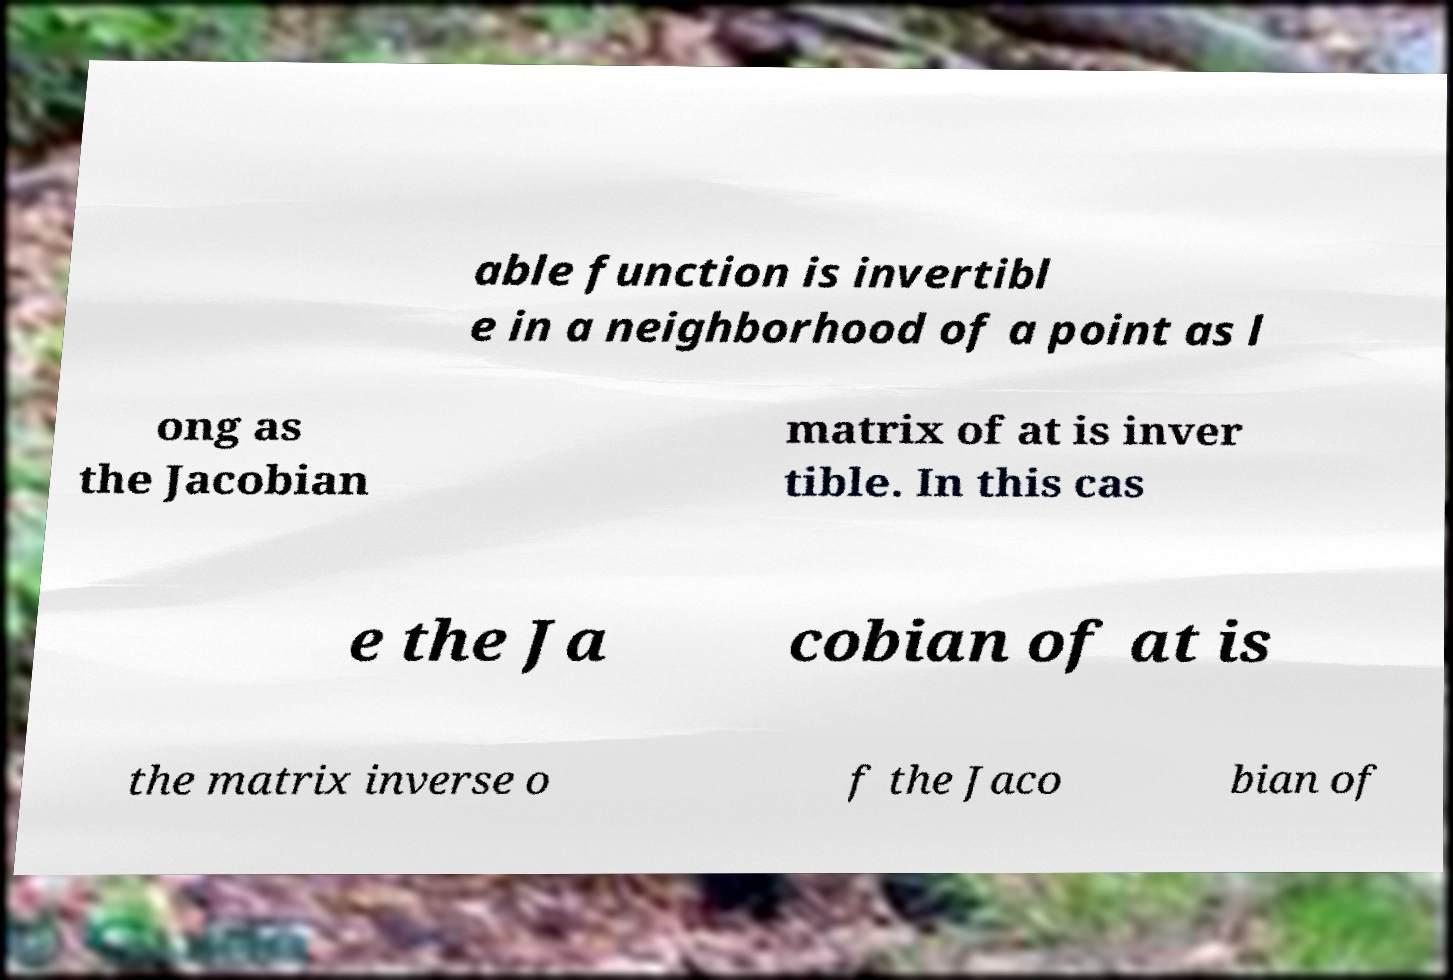Can you accurately transcribe the text from the provided image for me? able function is invertibl e in a neighborhood of a point as l ong as the Jacobian matrix of at is inver tible. In this cas e the Ja cobian of at is the matrix inverse o f the Jaco bian of 